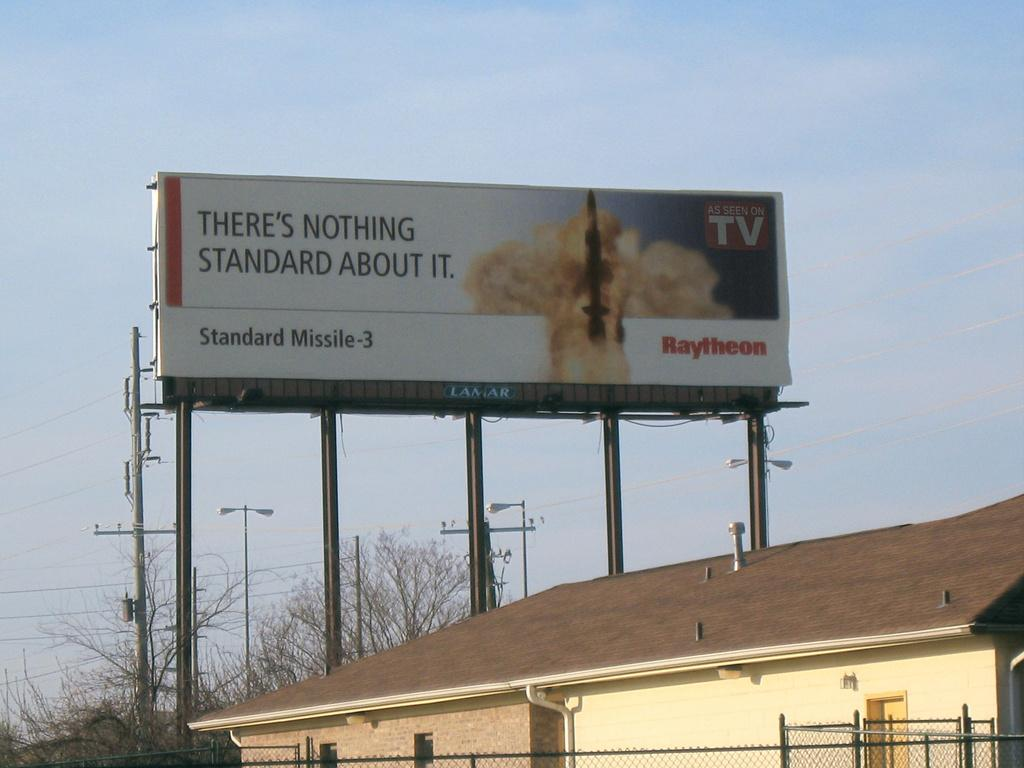Provide a one-sentence caption for the provided image. A billboard advertising a missile hanging over someone houses. 